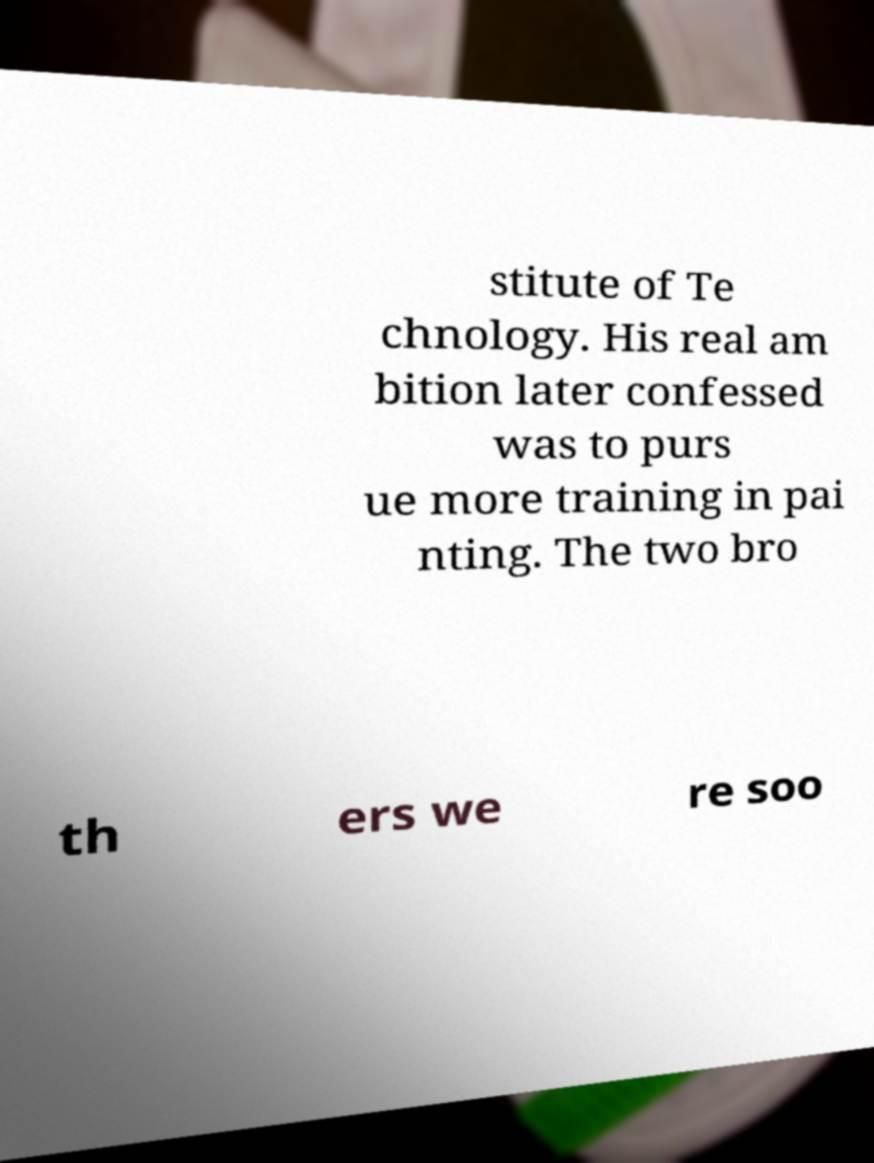For documentation purposes, I need the text within this image transcribed. Could you provide that? stitute of Te chnology. His real am bition later confessed was to purs ue more training in pai nting. The two bro th ers we re soo 